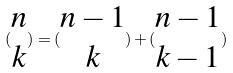Convert formula to latex. <formula><loc_0><loc_0><loc_500><loc_500>( \begin{matrix} n \\ k \end{matrix} ) = ( \begin{matrix} n - 1 \\ k \end{matrix} ) + ( \begin{matrix} n - 1 \\ k - 1 \end{matrix} )</formula> 